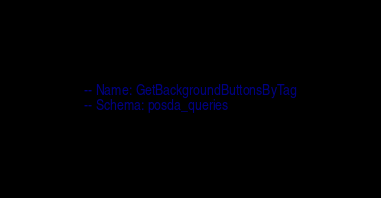<code> <loc_0><loc_0><loc_500><loc_500><_SQL_>-- Name: GetBackgroundButtonsByTag
-- Schema: posda_queries</code> 